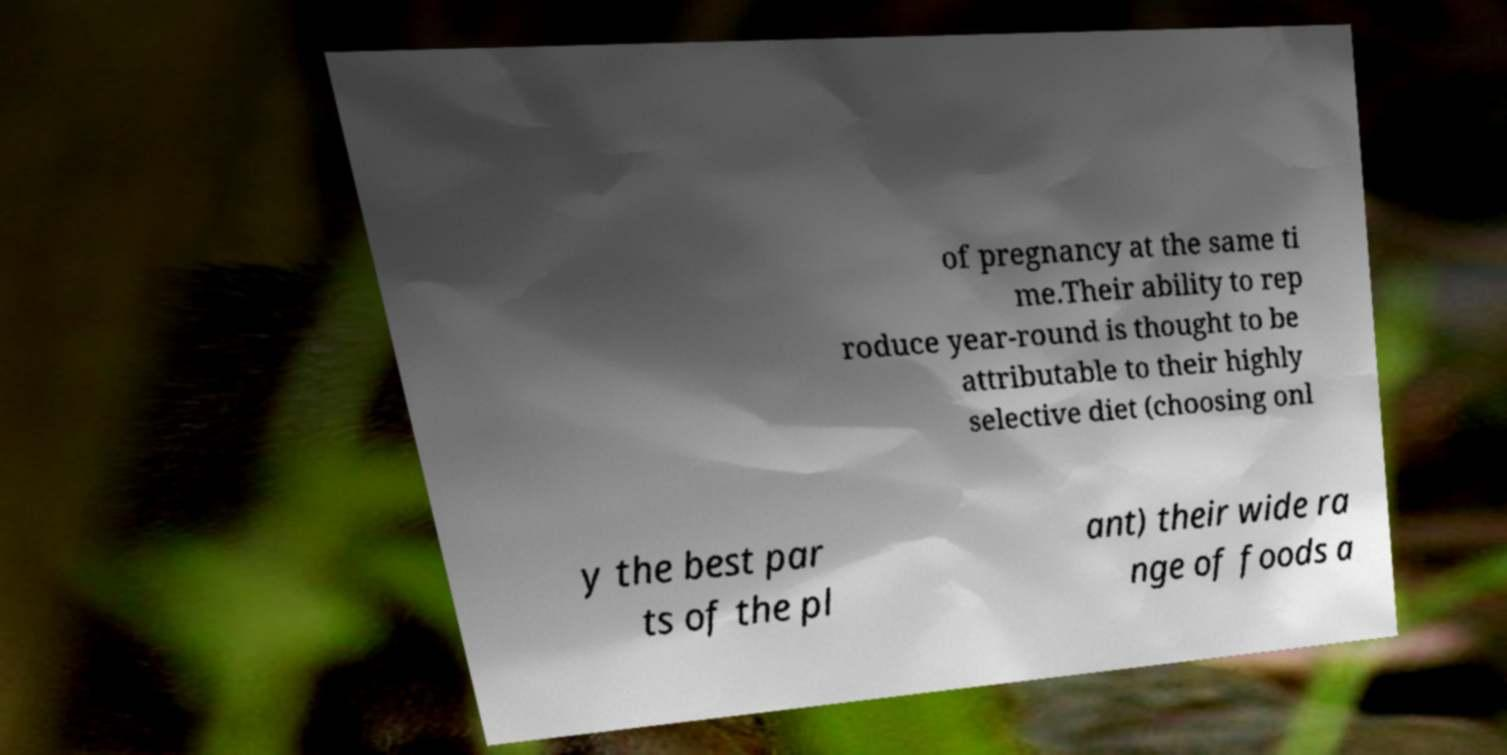Please read and relay the text visible in this image. What does it say? of pregnancy at the same ti me.Their ability to rep roduce year-round is thought to be attributable to their highly selective diet (choosing onl y the best par ts of the pl ant) their wide ra nge of foods a 